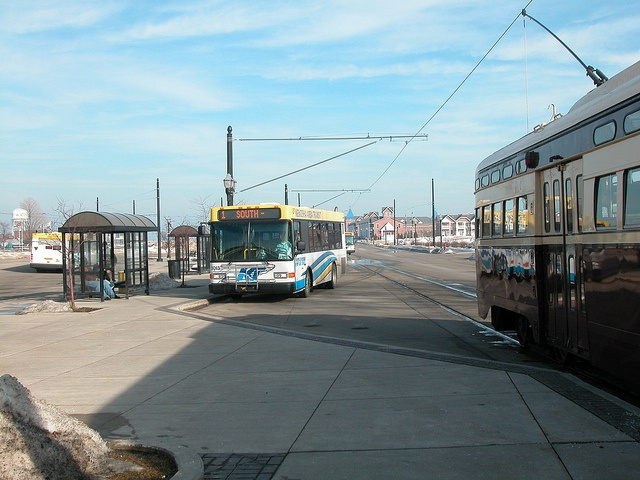Describe the objects in this image and their specific colors. I can see bus in lightblue, black, gray, and darkgray tones, bus in lightblue, black, gray, ivory, and teal tones, people in lightblue, gray, black, and darkgray tones, people in lightblue and teal tones, and bus in lightblue, gray, darkgray, white, and teal tones in this image. 